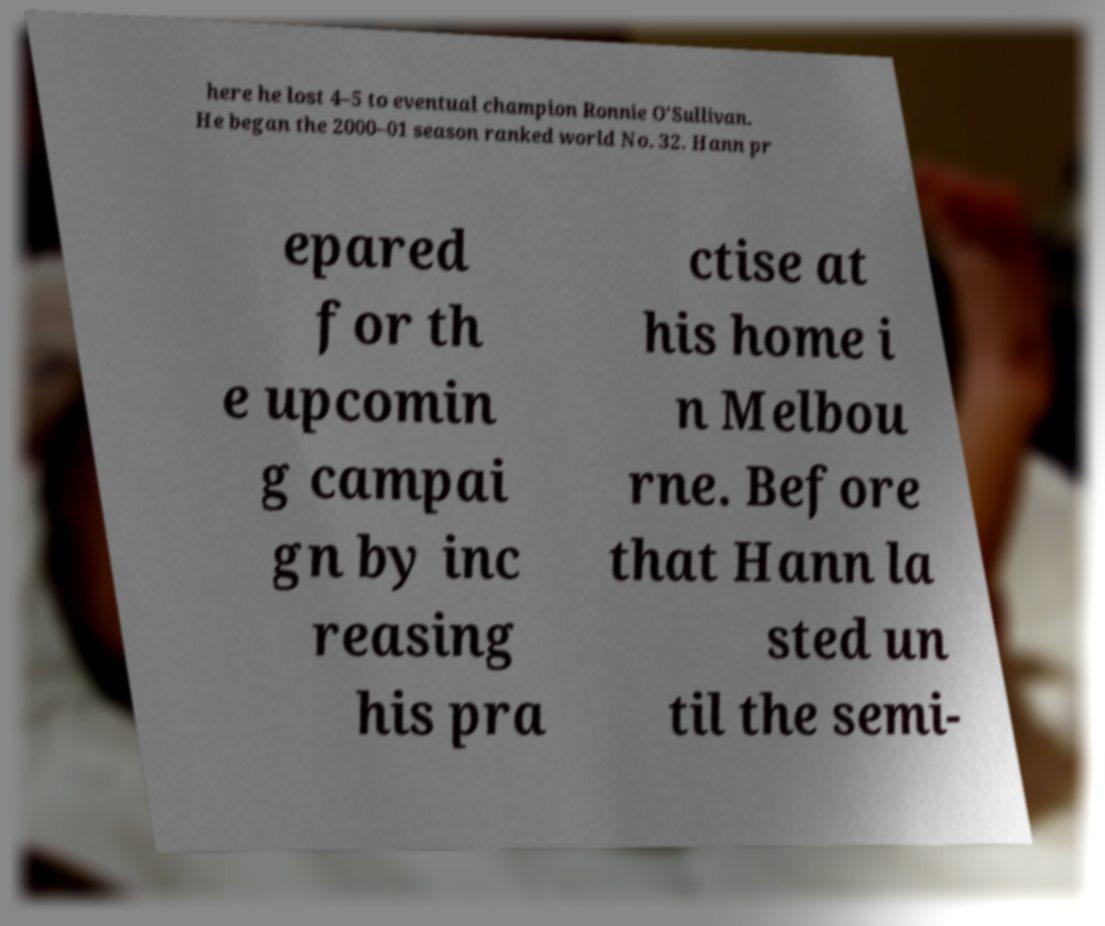There's text embedded in this image that I need extracted. Can you transcribe it verbatim? here he lost 4–5 to eventual champion Ronnie O'Sullivan. He began the 2000–01 season ranked world No. 32. Hann pr epared for th e upcomin g campai gn by inc reasing his pra ctise at his home i n Melbou rne. Before that Hann la sted un til the semi- 